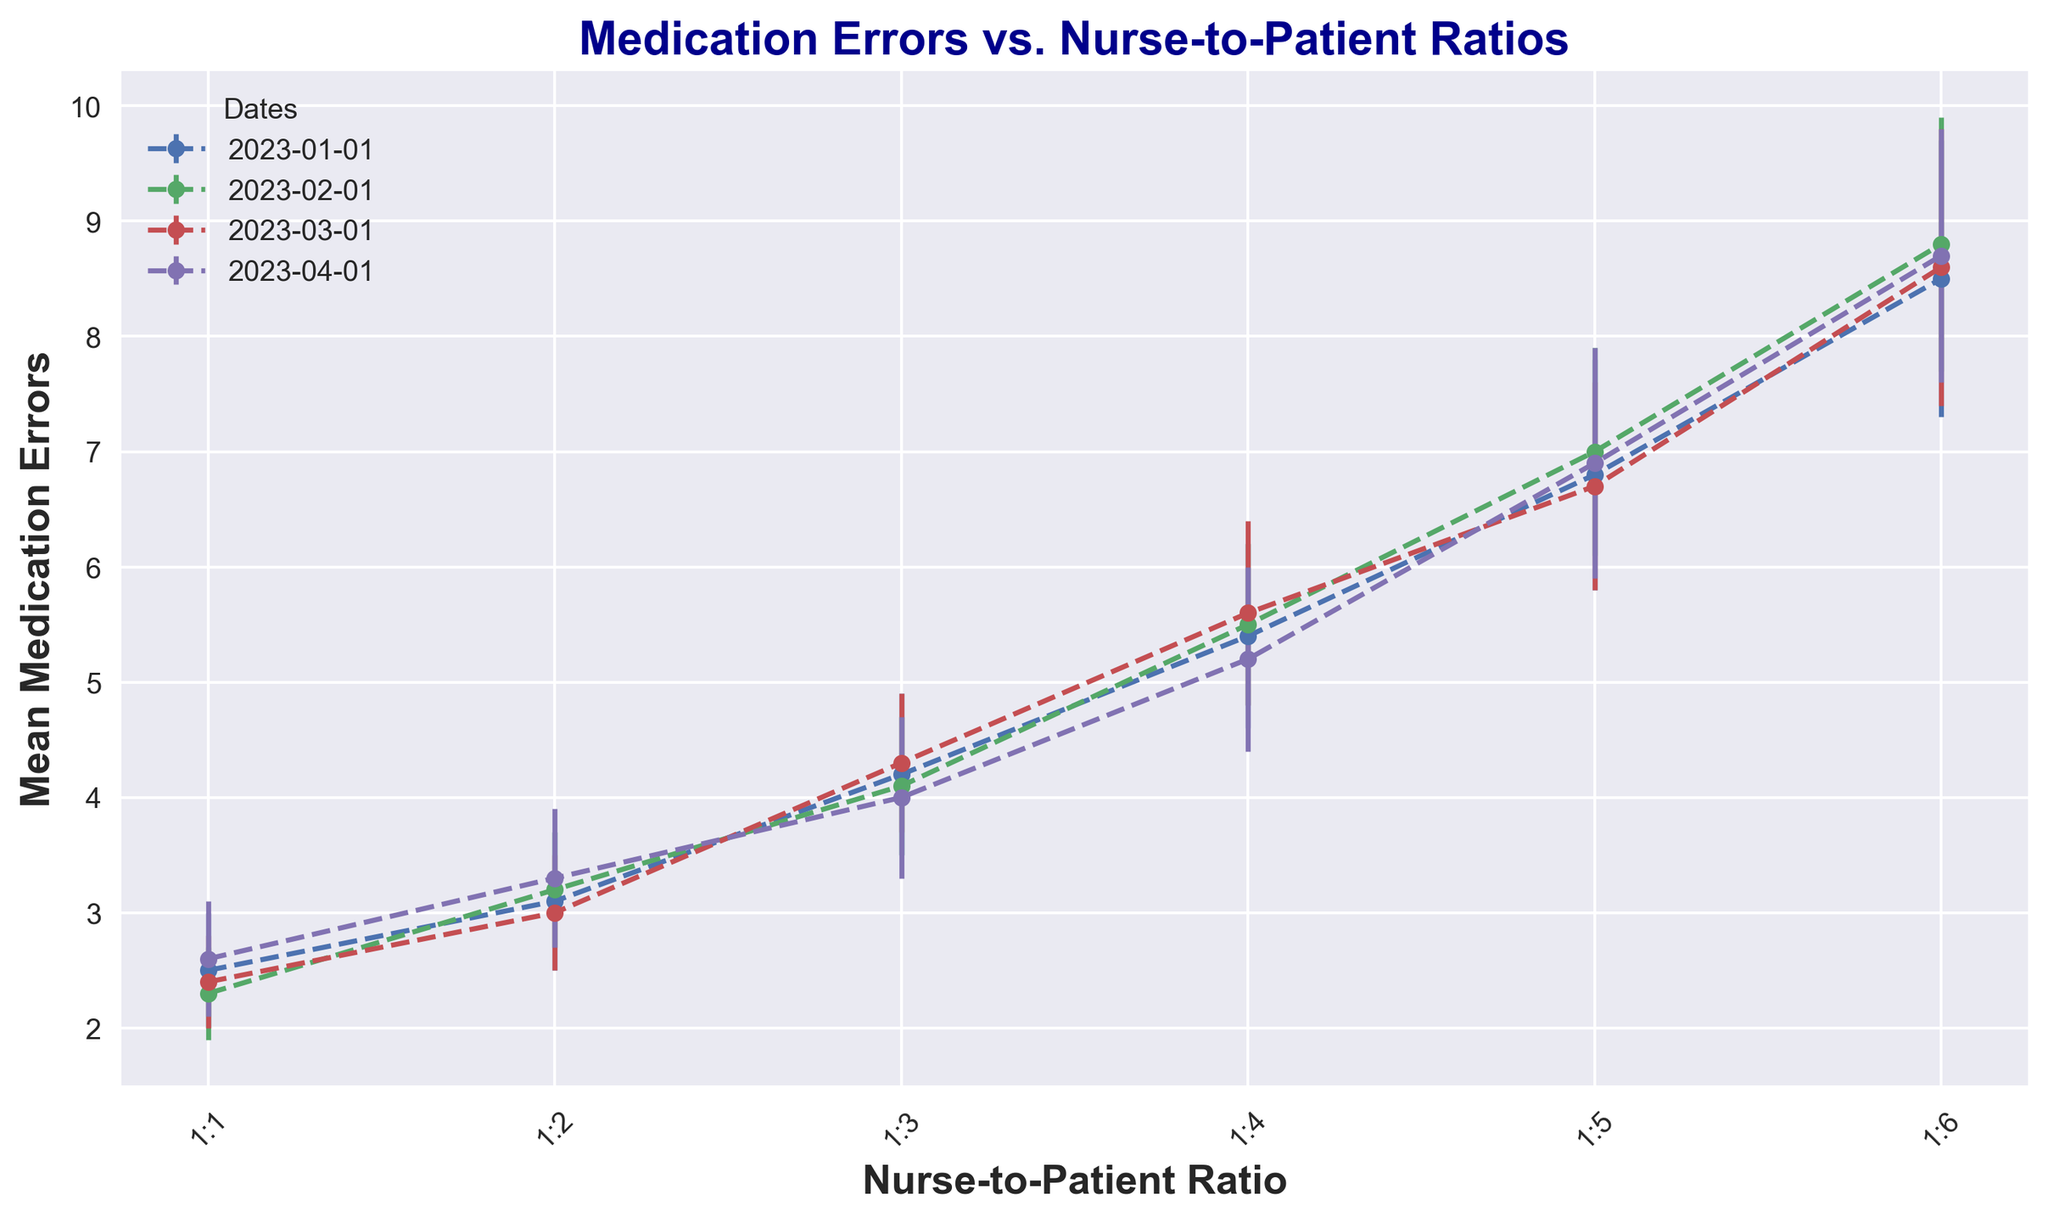Which nurse-to-patient ratio had the highest mean medication errors in January 2023? By examining the plot marked with the date "2023-01-01", we look for the highest mean medication error value among all ratios. The highest mean value corresponds to the ratio 1:6.
Answer: 1:6 How does the mean medication error at a ratio of 1:3 change from January 2023 to April 2023? Compare the mean medication error for the ratio of 1:3 on the dates 2023-01-01 and 2023-04-01. In January 2023, the mean is 4.2, and in April 2023, the mean is 4.0, indicating a decrease.
Answer: Decreases Which has greater variability in medication errors, 1:1 ratio in February 2023 or 1:6 ratio in March 2023? To determine variability, compare the standard deviations. For 1:1 ratio in February 2023, the standard deviation is 0.4, and for 1:6 ratio in March 2023, it is 1.2. Since 1.2 is higher, 1:6 ratio in March has greater variability.
Answer: 1:6 in March What is the approximate difference in mean medication errors between the nurse-to-patient ratios 1:4 and 1:5 in April 2023? Examine the mean medication errors for ratios 1:4 and 1:5 on the date 2023-04-01. The means are 5.2 and 6.9, respectively. Calculate the difference: 6.9 - 5.2 = 1.7.
Answer: 1.7 By how much did the average medication errors increase from a ratio of 1:1 to 1:6 in March 2023? Find the mean medication errors for ratios 1:1 and 1:6 on 2023-03-01. The means are 2.4 for 1:1 and 8.6 for 1:6. Calculate the increase: 8.6 - 2.4 = 6.2.
Answer: 6.2 Which date shows the most consistent medication errors across different nurse-to-patient ratios? Consistency can be assessed by the standard deviation across all ratios. By visually comparing error bars, the date with the shortest error bars overall appears to be February 2023.
Answer: February 2023 At the ratio of 1:4, which month has the smallest error margin in medication errors? The error margin is indicated by the length of the error bars. By comparing the error bars for the 1:4 ratio across all months, April 2023 has the smallest margin with a standard deviation of 0.8.
Answer: April 2023 Comparing the medication errors at ratio 1:2 between January and March 2023, which month has the higher mean? Look at the mean medication errors for ratio 1:2 in January 2023 and March 2023. In January 2023, the mean is 3.1, and in March 2023, it is 3.0. January has the higher mean.
Answer: January 2023 How does the trend of mean medication errors as nurse-to-patient ratio increases change from January to April 2023? Analyze the pattern of mean medication errors from 1:1 to 1:6 for both months. Both months show an increasing trend, meaning as the ratio increases, the mean medication errors also increase.
Answer: Increasing trend 